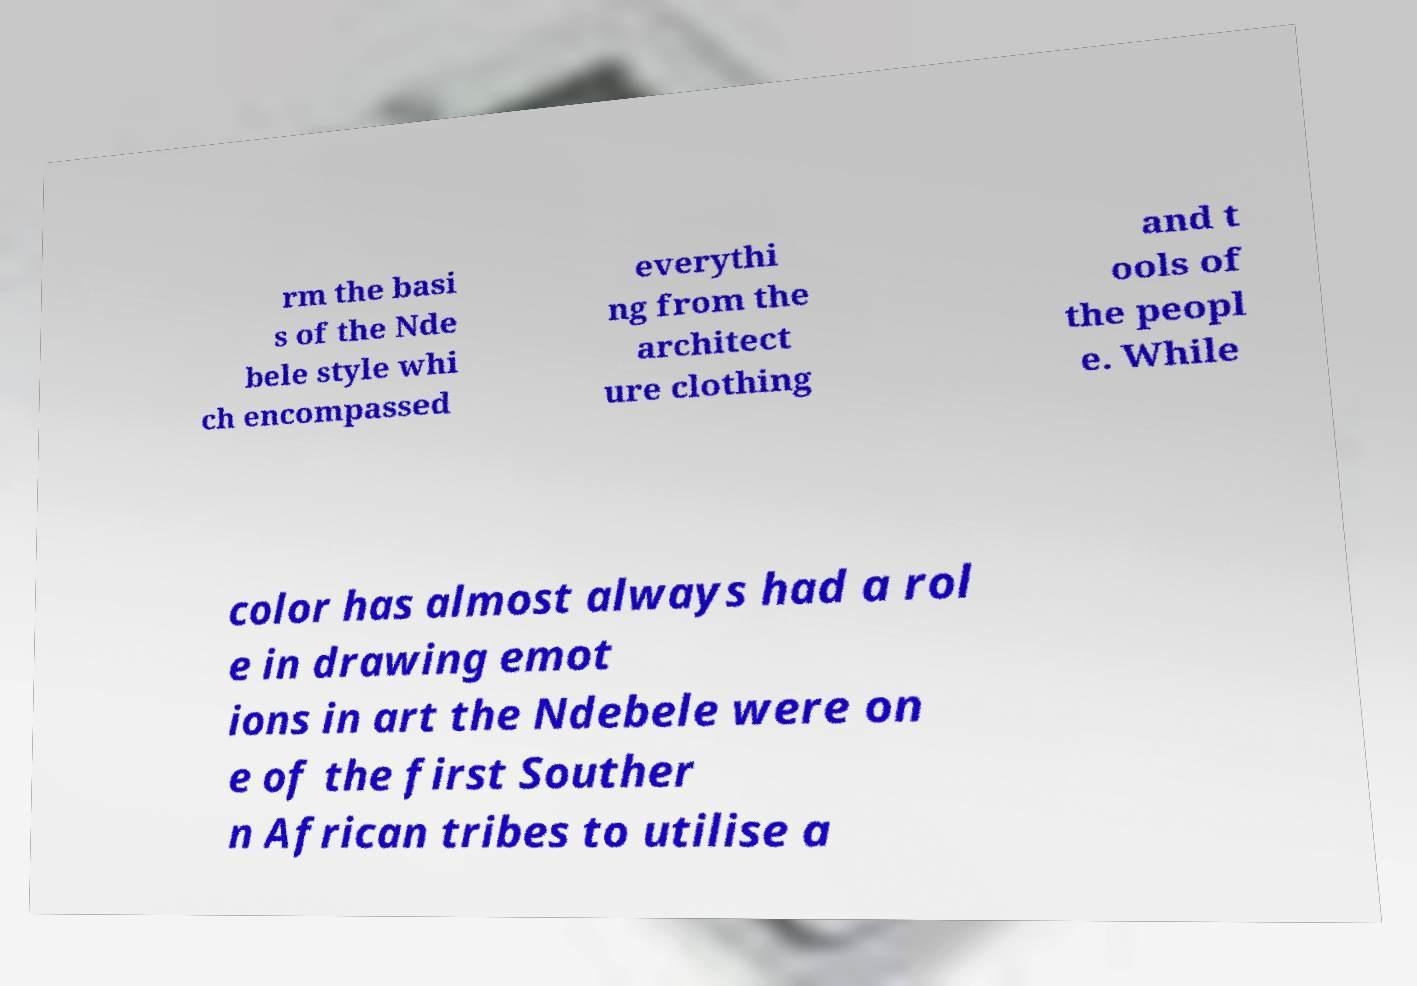There's text embedded in this image that I need extracted. Can you transcribe it verbatim? rm the basi s of the Nde bele style whi ch encompassed everythi ng from the architect ure clothing and t ools of the peopl e. While color has almost always had a rol e in drawing emot ions in art the Ndebele were on e of the first Souther n African tribes to utilise a 